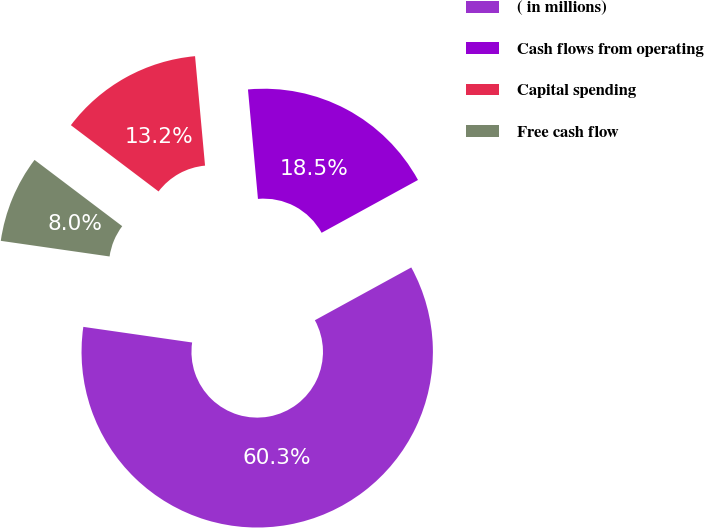<chart> <loc_0><loc_0><loc_500><loc_500><pie_chart><fcel>( in millions)<fcel>Cash flows from operating<fcel>Capital spending<fcel>Free cash flow<nl><fcel>60.25%<fcel>18.47%<fcel>13.25%<fcel>8.03%<nl></chart> 